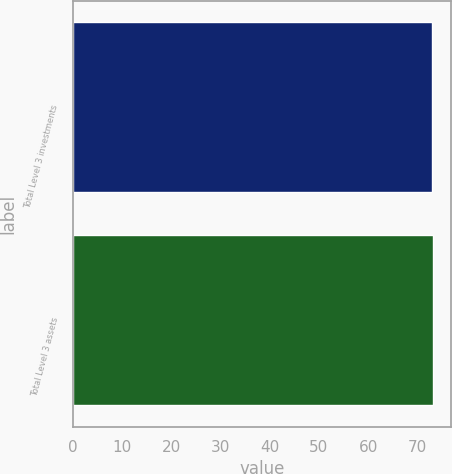Convert chart. <chart><loc_0><loc_0><loc_500><loc_500><bar_chart><fcel>Total Level 3 investments<fcel>Total Level 3 assets<nl><fcel>73<fcel>73.1<nl></chart> 